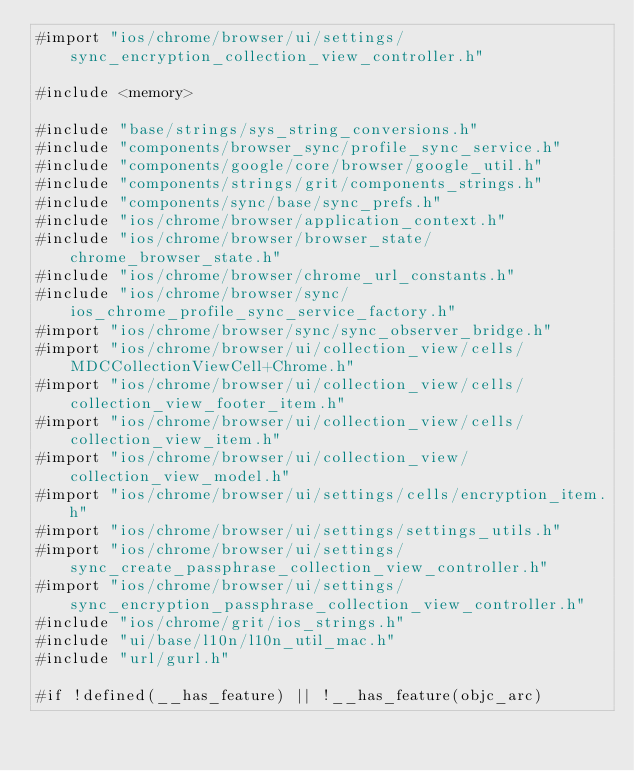Convert code to text. <code><loc_0><loc_0><loc_500><loc_500><_ObjectiveC_>#import "ios/chrome/browser/ui/settings/sync_encryption_collection_view_controller.h"

#include <memory>

#include "base/strings/sys_string_conversions.h"
#include "components/browser_sync/profile_sync_service.h"
#include "components/google/core/browser/google_util.h"
#include "components/strings/grit/components_strings.h"
#include "components/sync/base/sync_prefs.h"
#include "ios/chrome/browser/application_context.h"
#include "ios/chrome/browser/browser_state/chrome_browser_state.h"
#include "ios/chrome/browser/chrome_url_constants.h"
#include "ios/chrome/browser/sync/ios_chrome_profile_sync_service_factory.h"
#import "ios/chrome/browser/sync/sync_observer_bridge.h"
#import "ios/chrome/browser/ui/collection_view/cells/MDCCollectionViewCell+Chrome.h"
#import "ios/chrome/browser/ui/collection_view/cells/collection_view_footer_item.h"
#import "ios/chrome/browser/ui/collection_view/cells/collection_view_item.h"
#import "ios/chrome/browser/ui/collection_view/collection_view_model.h"
#import "ios/chrome/browser/ui/settings/cells/encryption_item.h"
#import "ios/chrome/browser/ui/settings/settings_utils.h"
#import "ios/chrome/browser/ui/settings/sync_create_passphrase_collection_view_controller.h"
#import "ios/chrome/browser/ui/settings/sync_encryption_passphrase_collection_view_controller.h"
#include "ios/chrome/grit/ios_strings.h"
#include "ui/base/l10n/l10n_util_mac.h"
#include "url/gurl.h"

#if !defined(__has_feature) || !__has_feature(objc_arc)</code> 